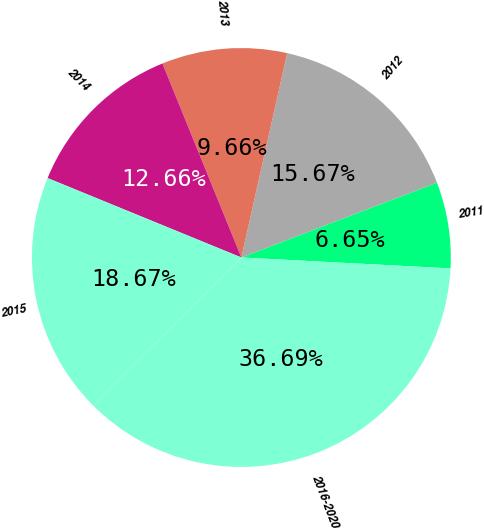<chart> <loc_0><loc_0><loc_500><loc_500><pie_chart><fcel>2011<fcel>2012<fcel>2013<fcel>2014<fcel>2015<fcel>2016-2020<nl><fcel>6.65%<fcel>15.67%<fcel>9.66%<fcel>12.66%<fcel>18.67%<fcel>36.69%<nl></chart> 